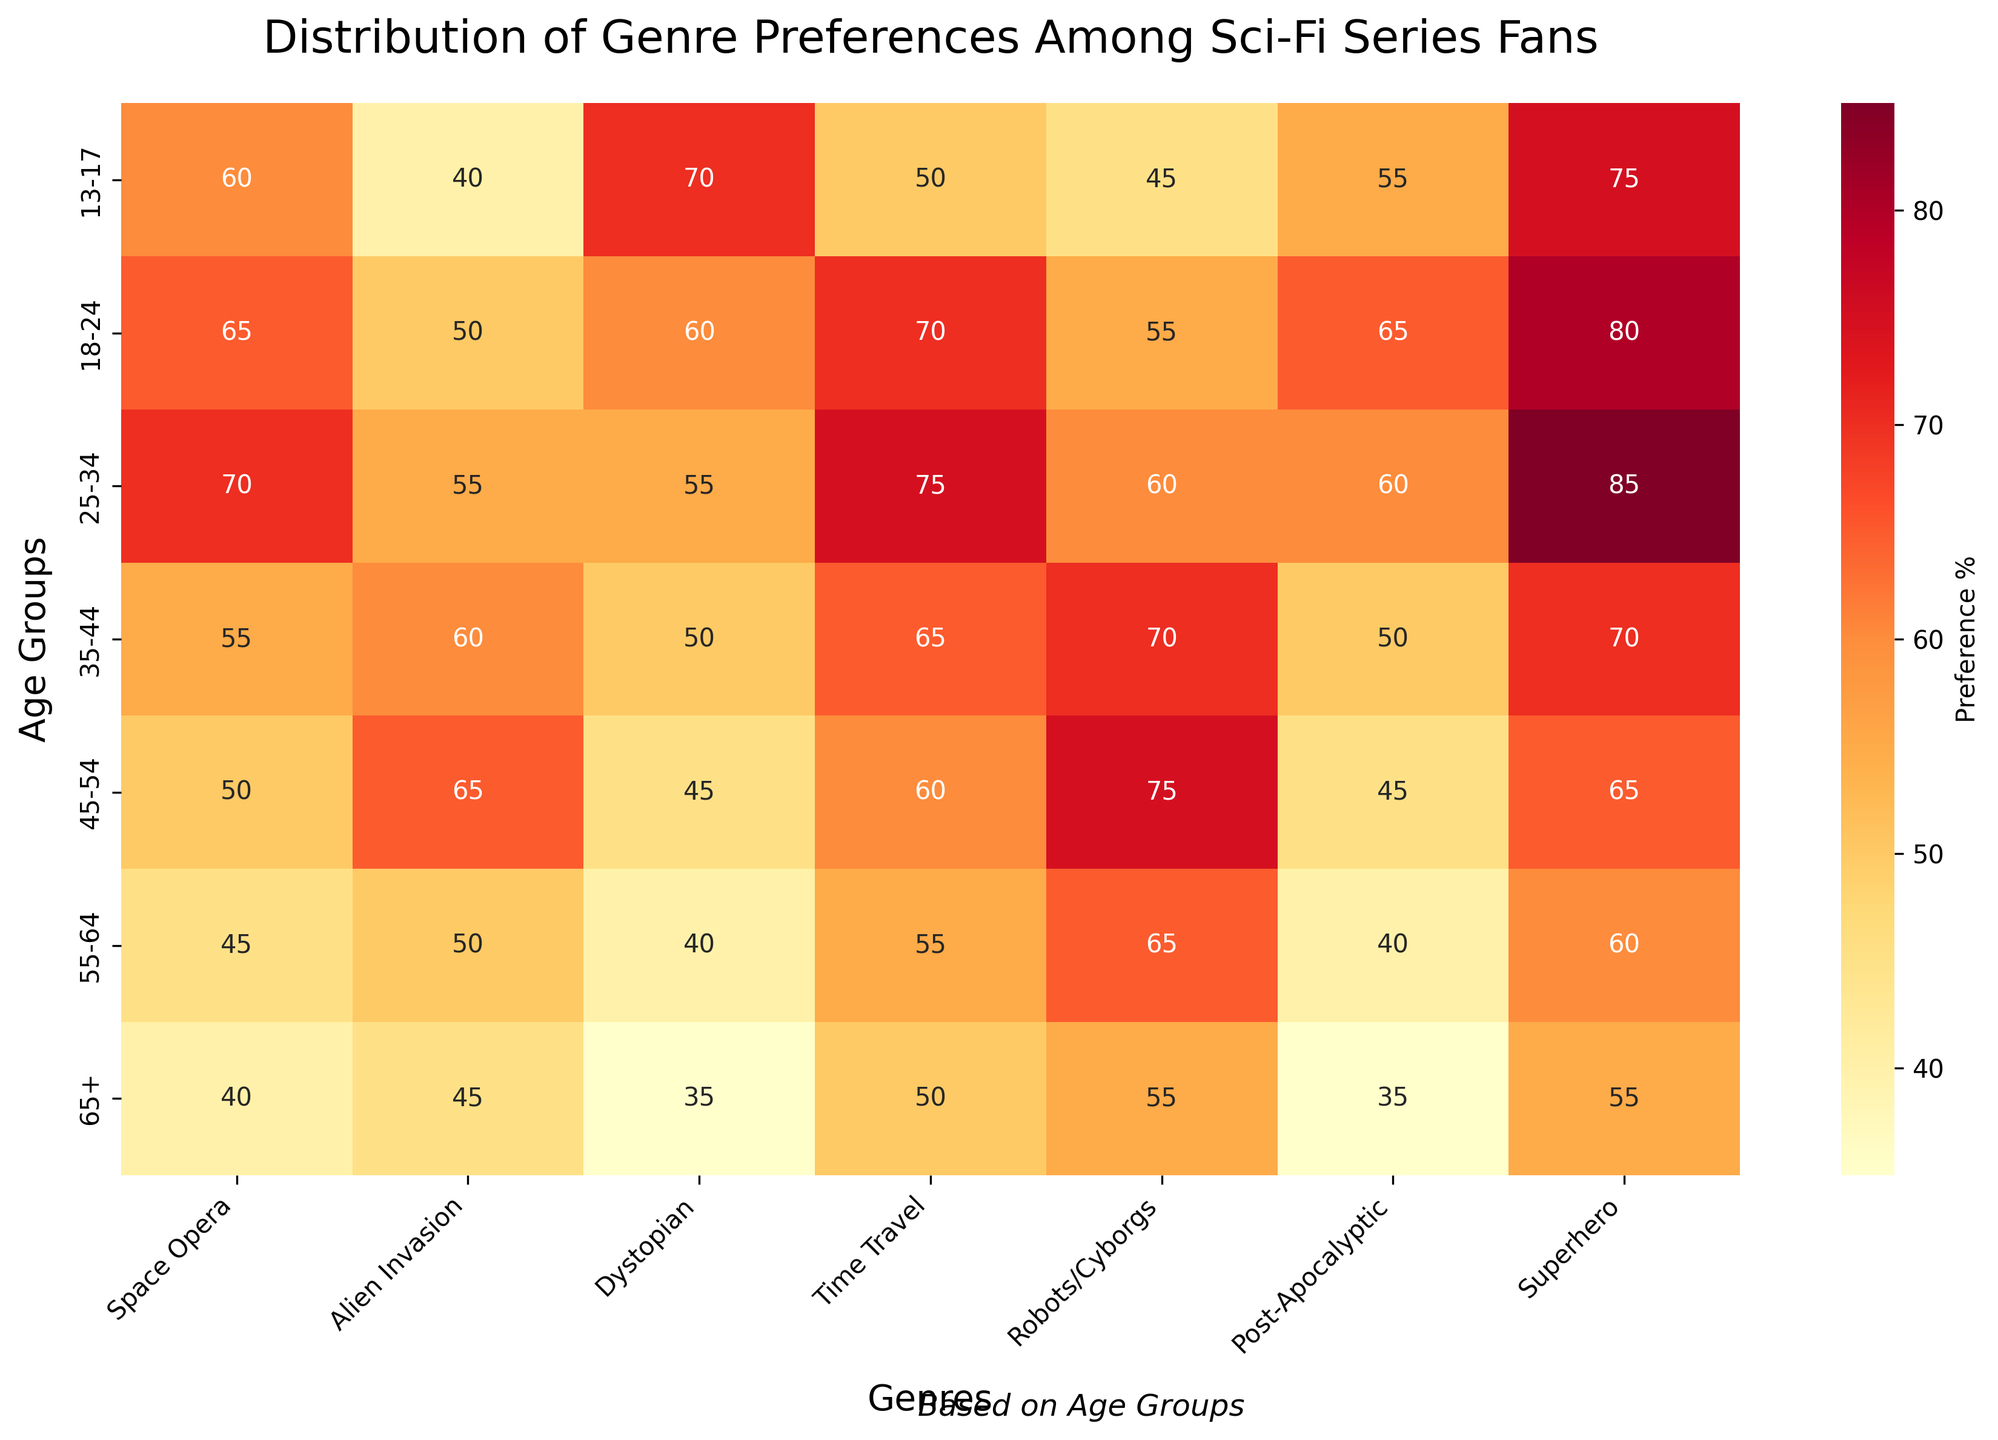What's the title of the heatmap? The title is displayed at the top center of the heatmap, summarizing the information it presents. It states: 'Distribution of Genre Preferences Among Sci-Fi Series Fans'.
Answer: Distribution of Genre Preferences Among Sci-Fi Series Fans Which age group prefers 'Time Travel' the most? To determine the age group that prefers 'Time Travel' the most, look at the 'Time Travel' column and find the highest number. The highest value in this column is 75, which corresponds to the 25-34 age group.
Answer: 25-34 Which genre has the highest total preference percentage across all age groups? To find the genre with the highest total preference, sum the values for each genre column and compare them. 'Superhero' has the highest total with values 75 + 80 + 85 + 70 + 65 + 60 + 55, totaling 490.
Answer: Superhero What's the preference percentage difference for 'Robots/Cyborgs' between the 18-24 and 35-44 age groups? Subtract the 'Robots/Cyborgs' preference percentage for the 35-44 age group (70) from that of the 18-24 age group (55). Therefore, 70 - 55 = 15.
Answer: 15 Which age group has the lowest preference for 'Post-Apocalyptic' genres? Look at the 'Post-Apocalyptic' column, and identify the age group with the smallest value. The lowest value is 35 for the 65+ age group.
Answer: 65+ What's the difference in the preference percentage for 'Alien Invasion' between the youngest (13-17) and the oldest age groups (65+)? Subtract the 'Alien Invasion' preference percentage for the 65+ age group (45) from that of the 13-17 age group (40). Therefore, 45 - 40 = 5.
Answer: 5 Which genre sees a consistent decline in preference as the age group increases? To identify a consistent decline, observe the values in each genre column from the youngest to the oldest age group. The 'Superhero' genre shows this pattern: 75, 80, 85, 70, 65, 60, 55.
Answer: Superhero What's the combined preference percentage for 'Space Opera' and 'Dystopian' in the 45-54 age group? Add the preference percentages for 'Space Opera' (50) and 'Dystopian' (45) in the 45-54 age group. Therefore, 50 + 45 = 95.
Answer: 95 Is the preference for 'Space Opera' in the 25-34 age group higher than the preference for 'Robots/Cyborgs' in the same age group? Compare the values for the 'Space Opera' (70) and 'Robots/Cyborgs' (60) columns in the 25-34 age group. Since 70 is greater than 60, the answer is yes.
Answer: Yes Which age group has a preference percentage for 'Alien Invasion' closer to the preference for 'Superhero' in the 55-64 age group? The preference percentage for 'Superhero' in the 55-64 age group is 60. Look for 'Alien Invasion' values closest to 60. The 35-44 age group has a value of 60 for 'Alien Invasion', which exactly matches.
Answer: 35-44 